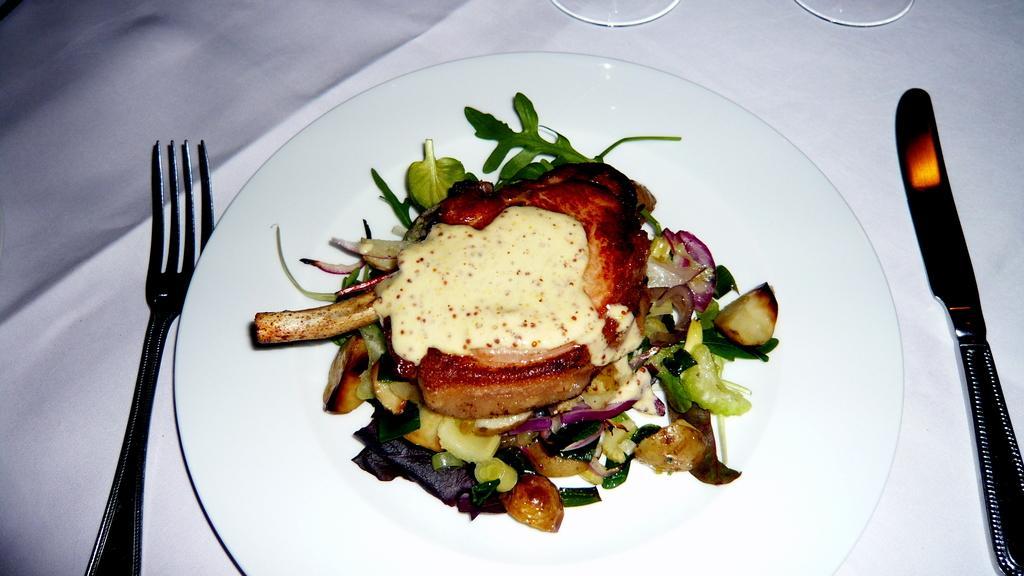Could you give a brief overview of what you see in this image? There are food items in a white color plate, in the left side there is a fork and in the right side there is a knife. 